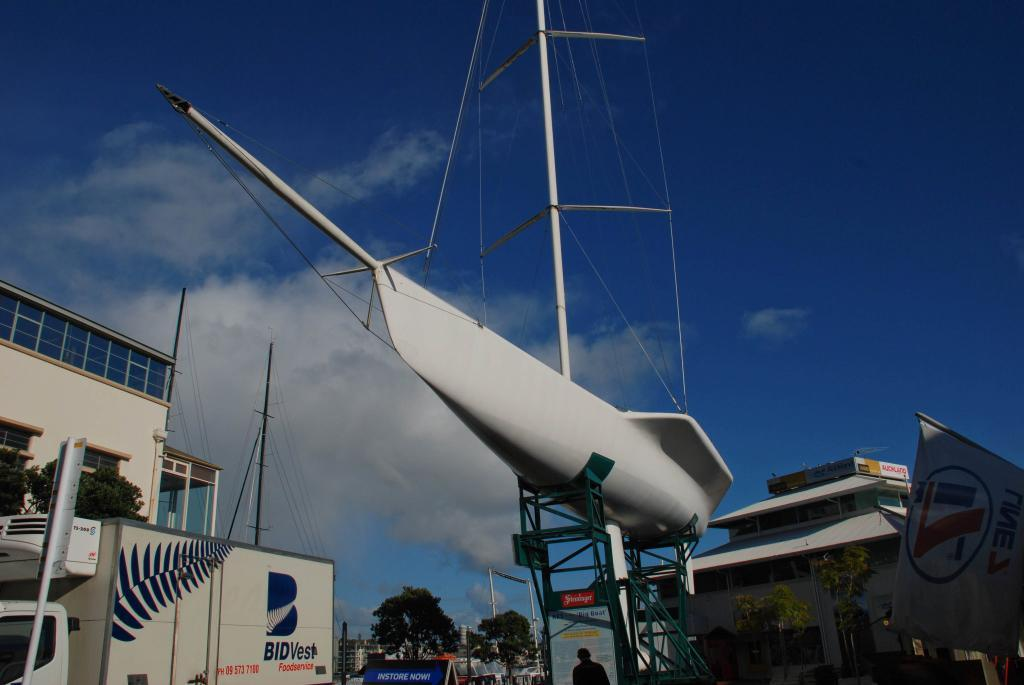What types of man-made structures can be seen in the image? There are buildings in the image. What else can be seen in the image besides buildings? There are vehicles, trees, and a white object visible in the image. Where is the banner located in the image? The banner is on the right side of the image. How would you describe the sky in the image? The sky is blue and cloudy in the image. How many apples are hanging from the trees in the image? There are no apples present in the image; it only features trees. What is the rate of the vehicles moving in the image? The image does not provide information about the speed or rate of the vehicles, so it cannot be determined. 